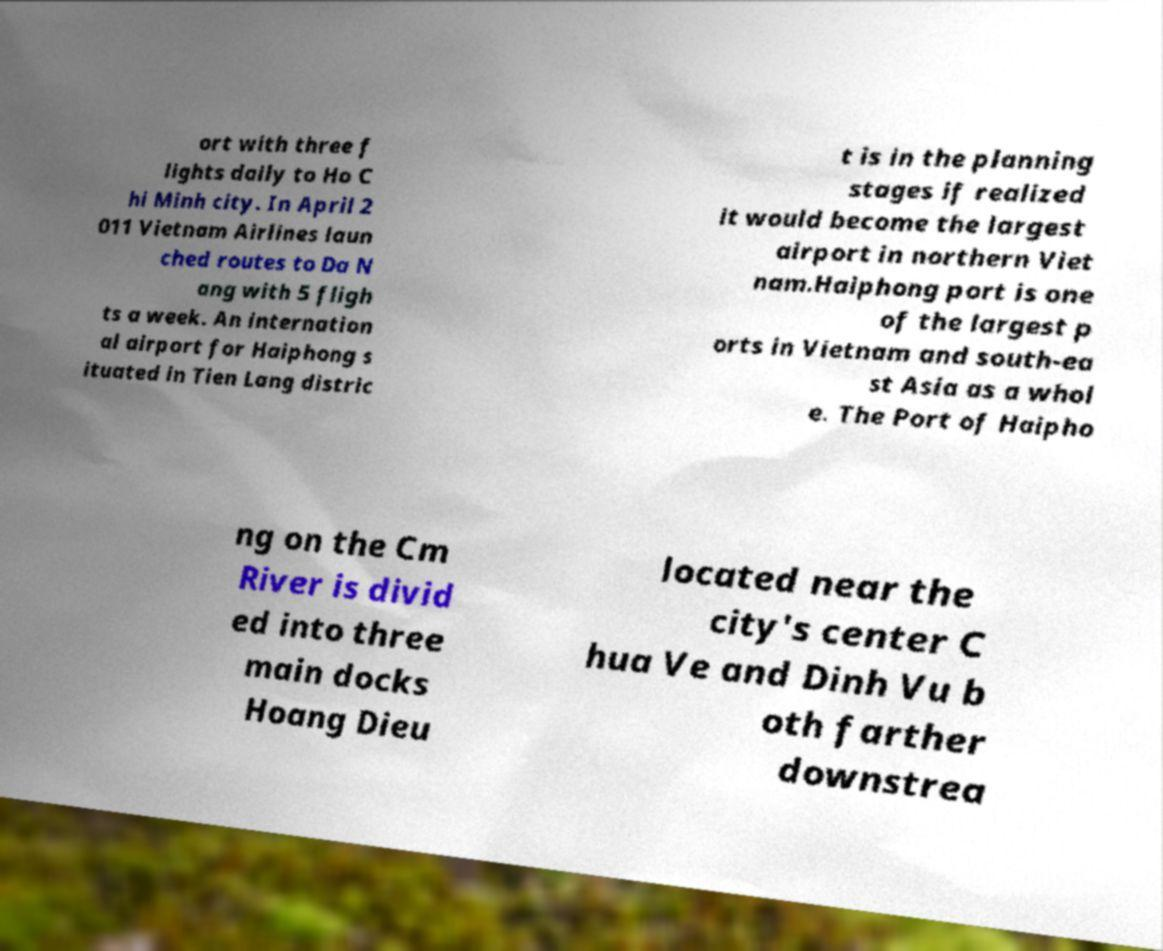There's text embedded in this image that I need extracted. Can you transcribe it verbatim? ort with three f lights daily to Ho C hi Minh city. In April 2 011 Vietnam Airlines laun ched routes to Da N ang with 5 fligh ts a week. An internation al airport for Haiphong s ituated in Tien Lang distric t is in the planning stages if realized it would become the largest airport in northern Viet nam.Haiphong port is one of the largest p orts in Vietnam and south-ea st Asia as a whol e. The Port of Haipho ng on the Cm River is divid ed into three main docks Hoang Dieu located near the city's center C hua Ve and Dinh Vu b oth farther downstrea 